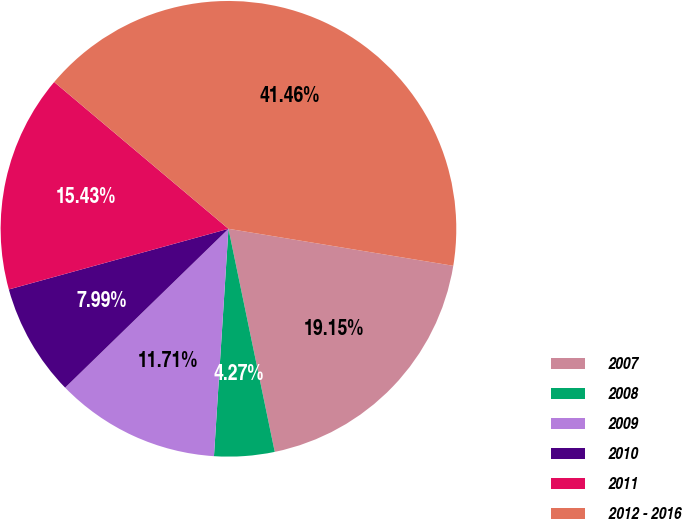<chart> <loc_0><loc_0><loc_500><loc_500><pie_chart><fcel>2007<fcel>2008<fcel>2009<fcel>2010<fcel>2011<fcel>2012 - 2016<nl><fcel>19.15%<fcel>4.27%<fcel>11.71%<fcel>7.99%<fcel>15.43%<fcel>41.46%<nl></chart> 